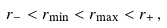<formula> <loc_0><loc_0><loc_500><loc_500>r _ { - } < r _ { \min } < r _ { \max } < r _ { + } \, ,</formula> 